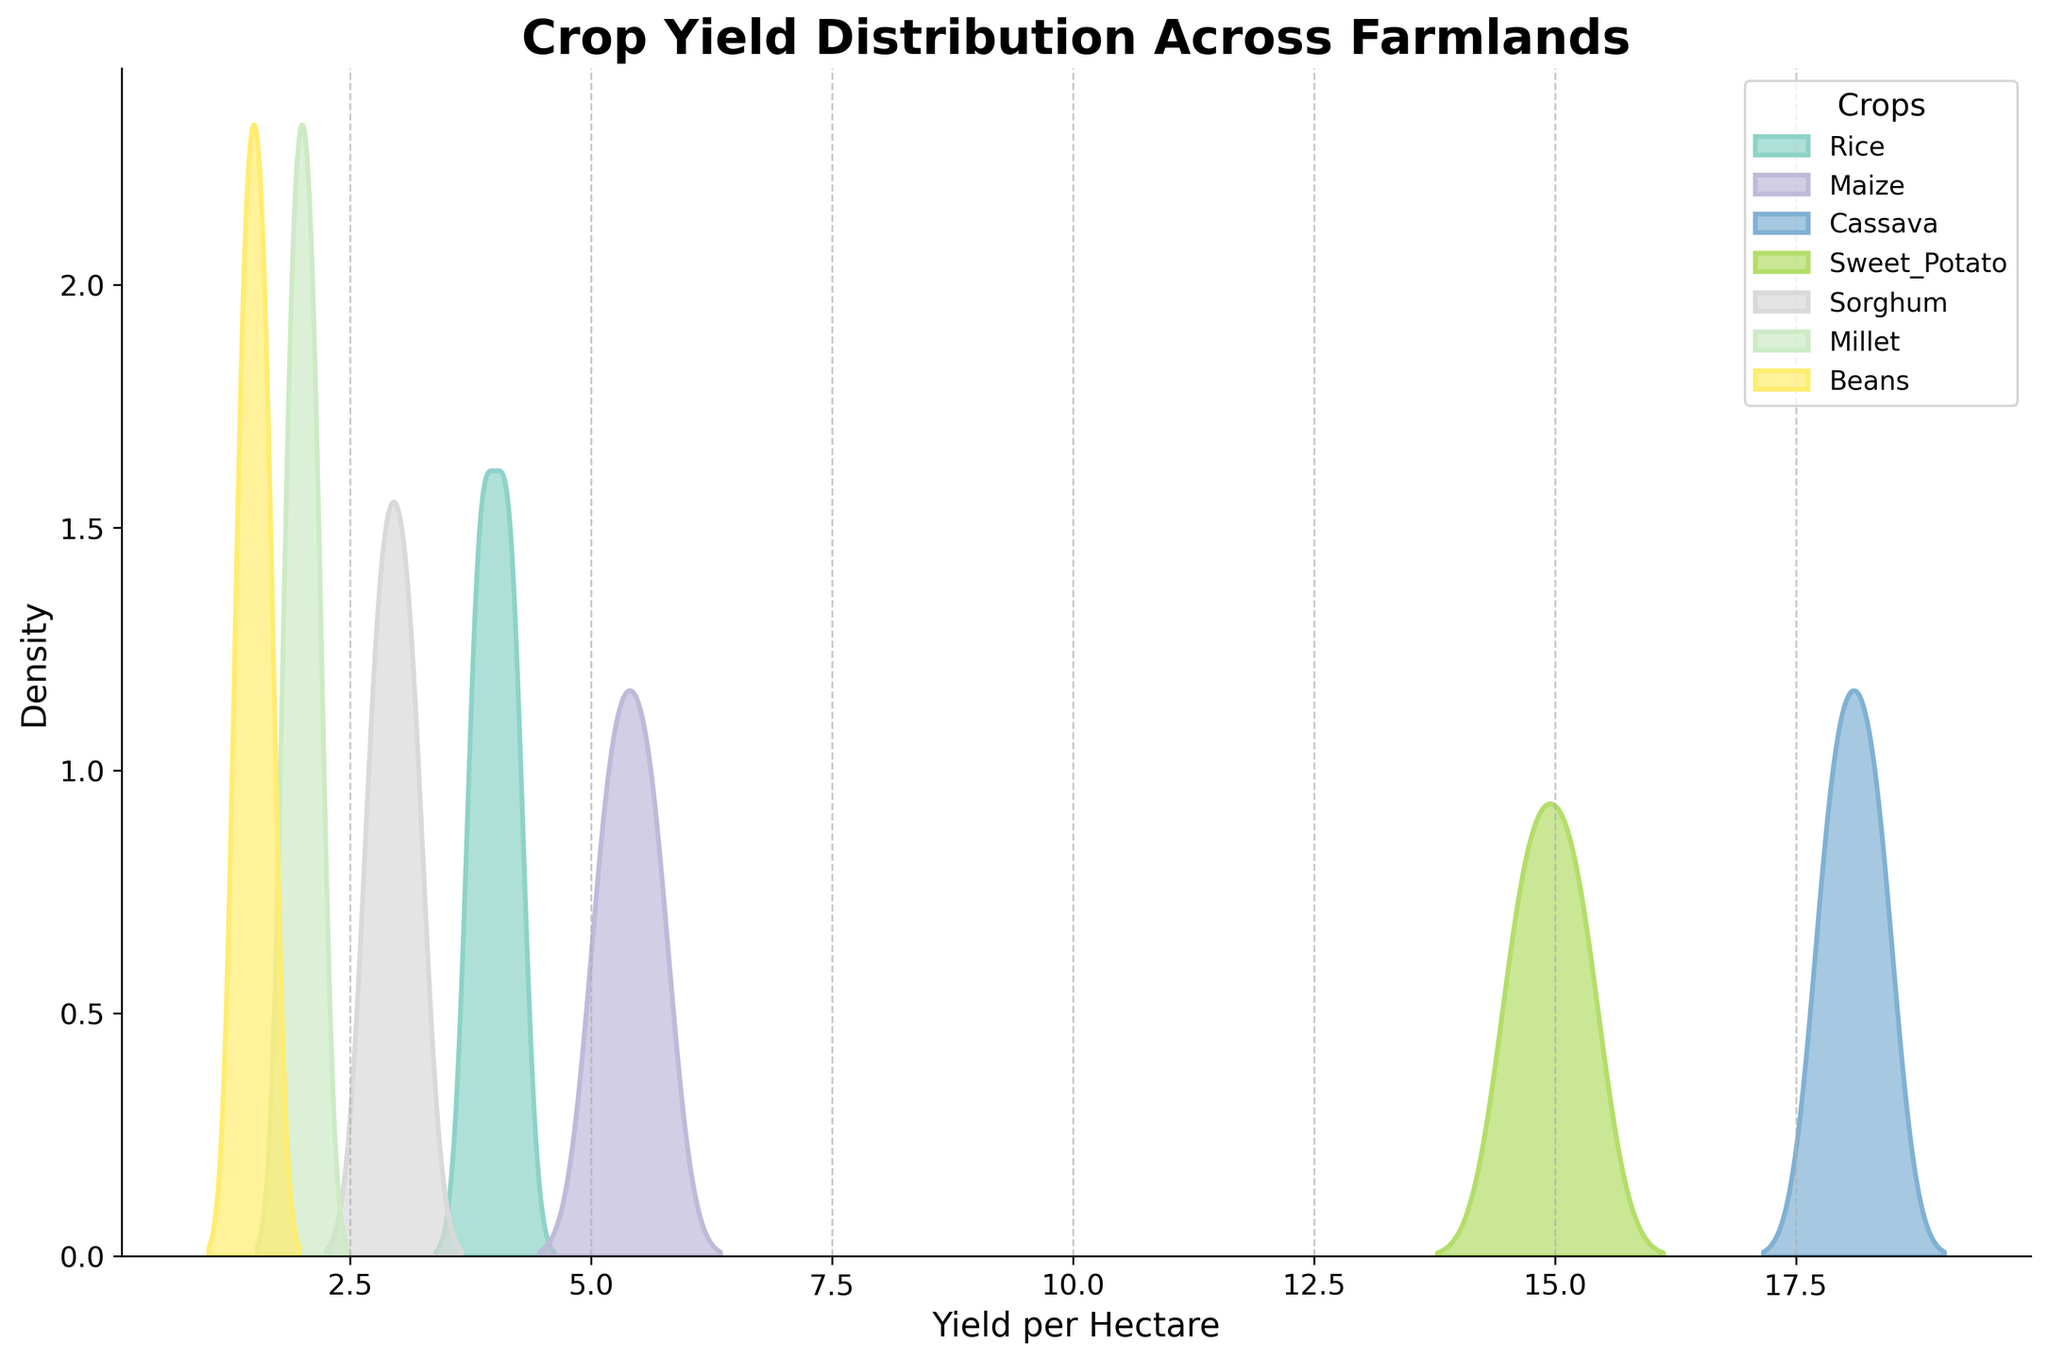What's the title of the figure? The title of the figure is displayed at the top of the plot, detailing the information being presented.
Answer: Crop Yield Distribution Across Farmlands What does the x-axis represent? The x-axis is labeled 'Yield per Hectare', indicating the horizontal axis represents the yield of various crops in hectares.
Answer: Yield per Hectare Which crop has the highest peak density in the plot? By observing the height of the peaks in the density plot, the crop with the highest peak can be identified.
Answer: Cassava Which crop's yield is spread across the broadest range? Identifying the crop with the widest spread of density along the x-axis will tell us which crop has the most varied yields.
Answer: Sweet Potato Are there any crops with overlapping yields? If so, which ones? By visually inspecting the density curves, we can identify if any crop densities overlap on the x-axis, indicating similar yield ranges.
Answer: Rice and Sorghum What's the crop with the lowest maximum yield per hectare shown in the plot? By determining the lowest point on the x-axis where the density is the highest for any crop, the crop with the smallest maximum yield can be found.
Answer: Beans Compare the yield variation between Rice and Maize. Which one shows more consistency? Comparing the breadth and height of the density curves will help determine which crop has a more consistent yield. Consistency is indicated by a narrower and taller peak.
Answer: Rice How does the variation of Sorghum yields compare to that of Cassava? By comparing the spread and peak height of the density plots of Sorghum and Cassava, we can determine their relative yield variations. Sorghum’s density curve is both narrower and lower than Cassava’s. Cassava shows a broader range and higher density peak.
Answer: Sorghum shows less variation Which crops have very similar yield distributions? Provide an example. By identifying density curves that closely overlap and follow a similar shape, we can determine crops with similar yield distributions. An example could be found by visually comparing each plot.
Answer: Rice and Maize What is the range of yields for Sweet Potato? By observing the spread of the density curve for Sweet Potato on the x-axis, the range of its yields can be roughly estimated. The curve spans portions of the axis from approximately 14.7 to 15.2.
Answer: Approximately 14.7 to 15.2 